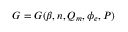<formula> <loc_0><loc_0><loc_500><loc_500>G = G ( \beta , n , Q _ { m } , \phi _ { e } , P )</formula> 